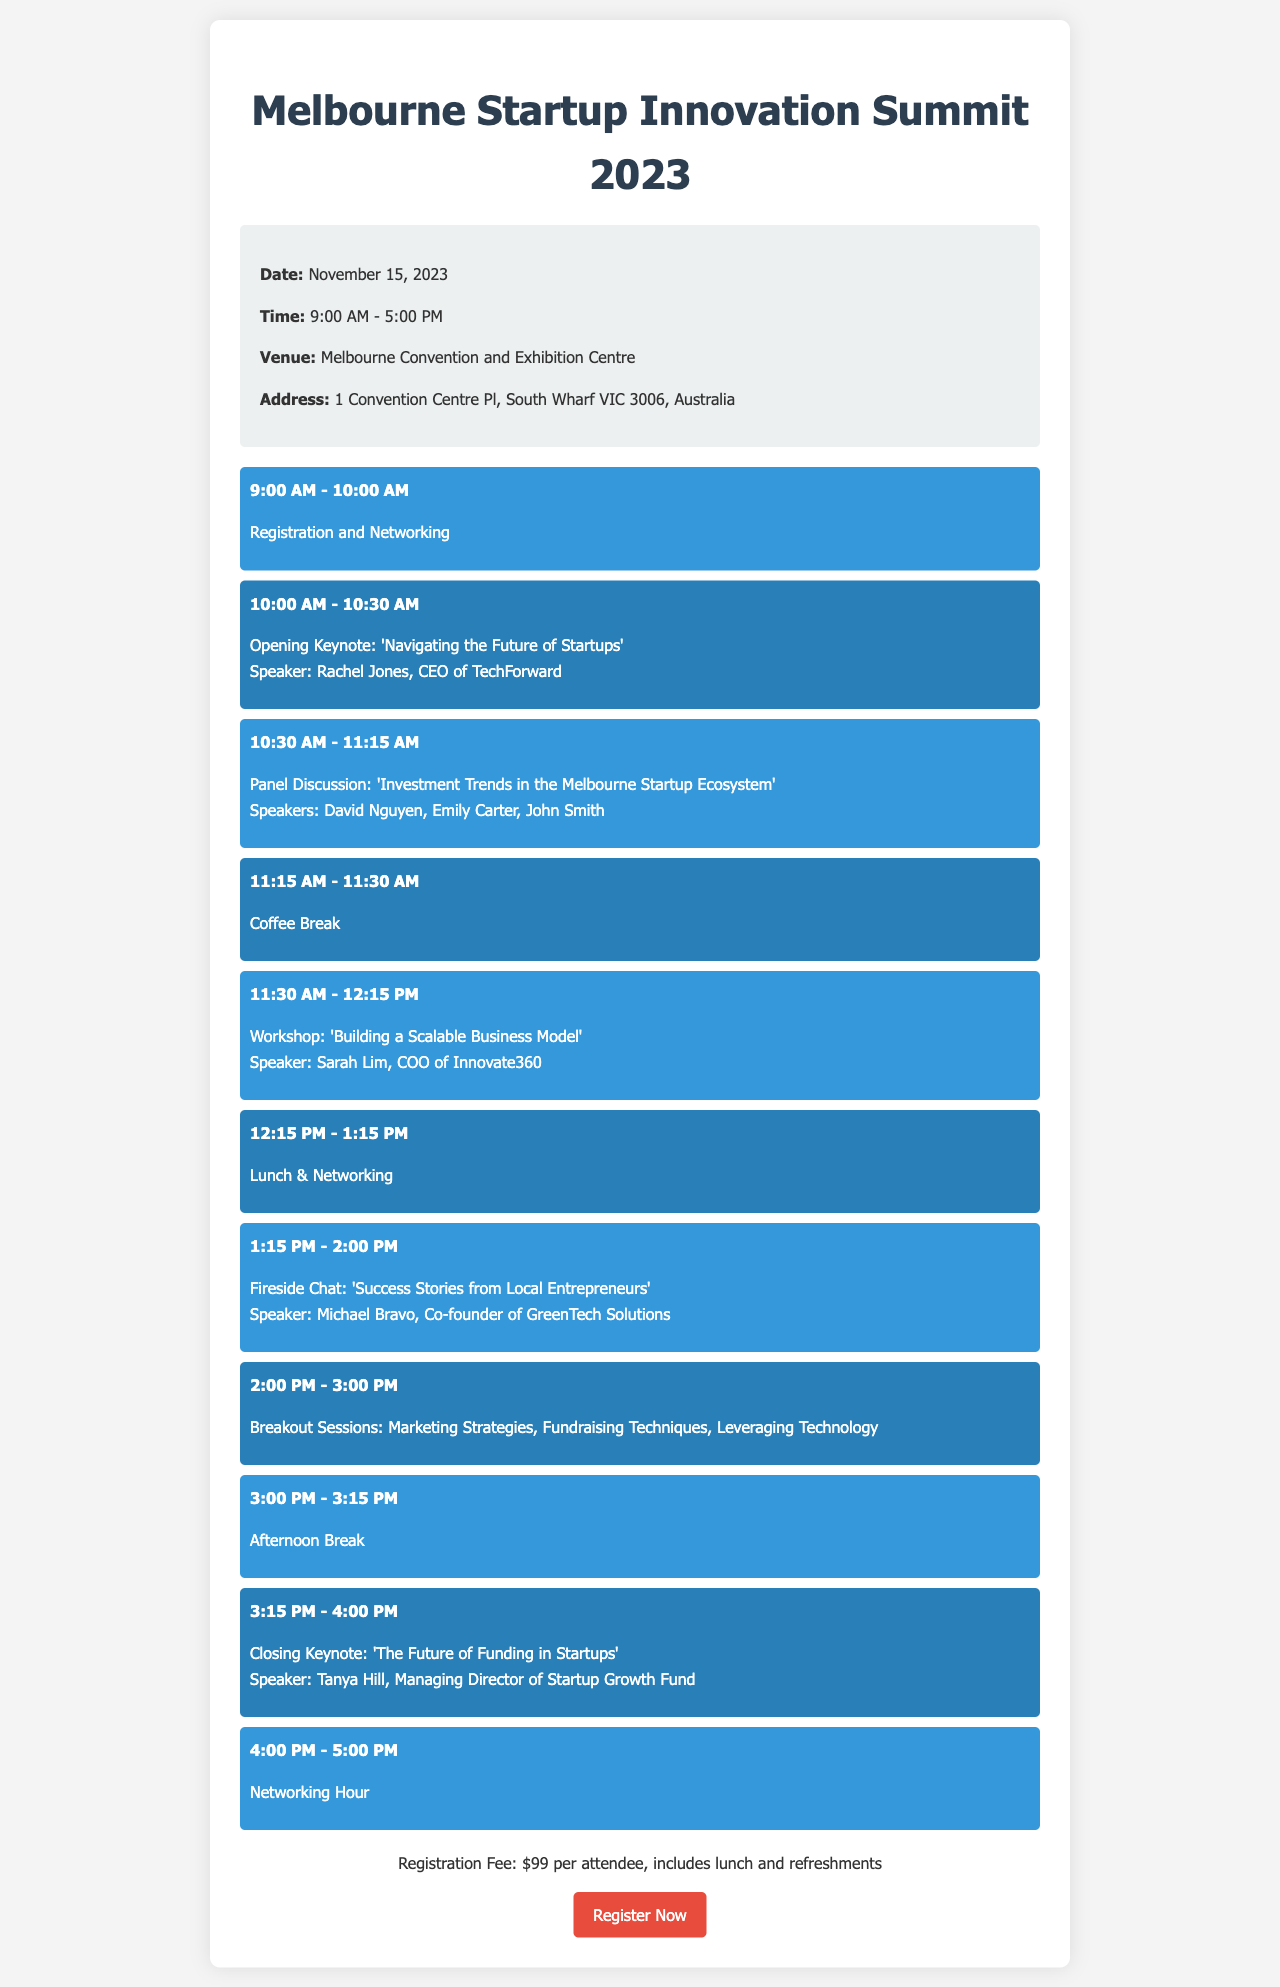What is the date of the event? The date is explicitly mentioned in the event details section of the document as November 15, 2023.
Answer: November 15, 2023 What is the venue name? The venue name is specified in the event details section, which states it is the Melbourne Convention and Exhibition Centre.
Answer: Melbourne Convention and Exhibition Centre Who is the opening keynote speaker? The opening keynote speaker is listed in the schedule, with the name Rachel Jones, CEO of TechForward.
Answer: Rachel Jones What time does registration start? The time for registration is included in the schedule and states it starts at 9:00 AM.
Answer: 9:00 AM How much is the registration fee? The registration fee is mentioned in the registration section of the document, which states it is $99 per attendee.
Answer: $99 Which workshop is scheduled after the coffee break? The document lists the workshops, stating that 'Building a Scalable Business Model' follows the coffee break.
Answer: Building a Scalable Business Model Who will be speaking at the closing keynote? The closing keynote speaker is mentioned in the schedule as Tanya Hill, Managing Director of Startup Growth Fund.
Answer: Tanya Hill What time is the networking hour? The document specifies that the networking hour is from 4:00 PM to 5:00 PM.
Answer: 4:00 PM - 5:00 PM What is the address of the venue? The venue address is detailed in the event details section as 1 Convention Centre Pl, South Wharf VIC 3006, Australia.
Answer: 1 Convention Centre Pl, South Wharf VIC 3006, Australia 